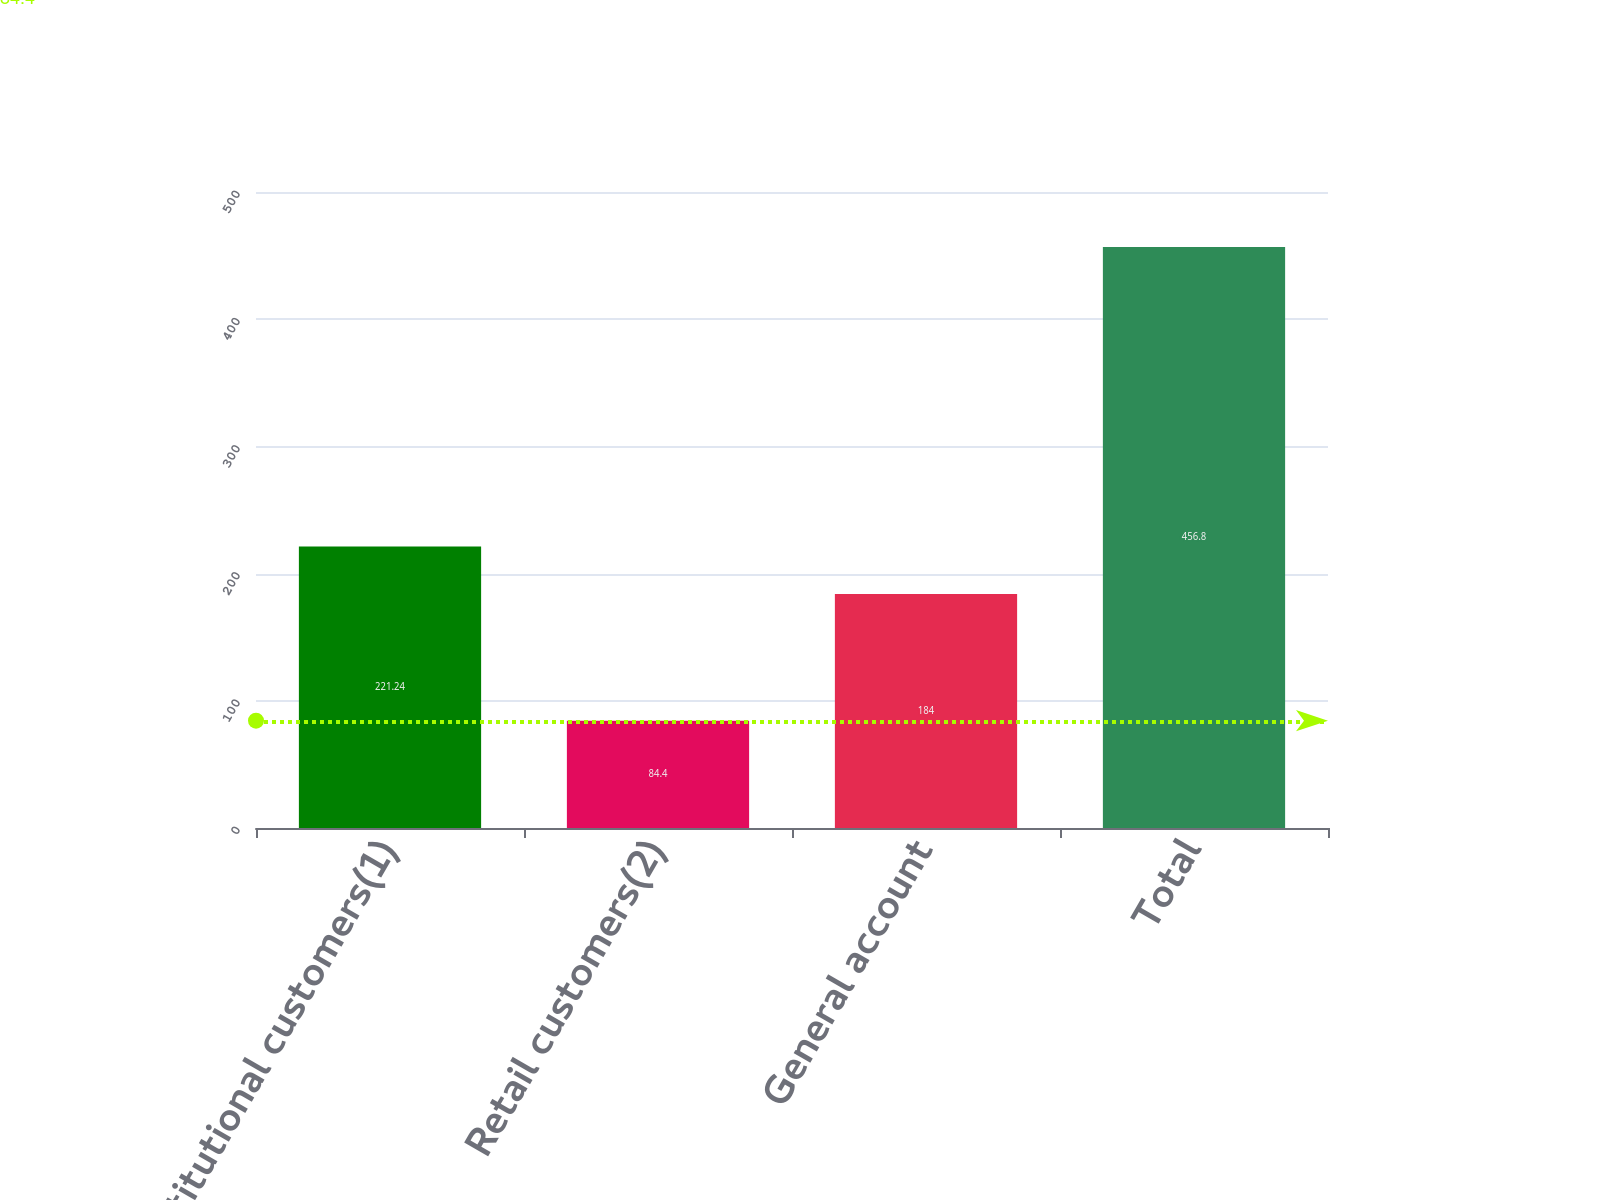Convert chart. <chart><loc_0><loc_0><loc_500><loc_500><bar_chart><fcel>Institutional customers(1)<fcel>Retail customers(2)<fcel>General account<fcel>Total<nl><fcel>221.24<fcel>84.4<fcel>184<fcel>456.8<nl></chart> 